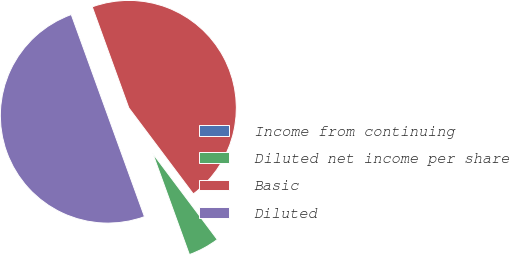<chart> <loc_0><loc_0><loc_500><loc_500><pie_chart><fcel>Income from continuing<fcel>Diluted net income per share<fcel>Basic<fcel>Diluted<nl><fcel>0.0%<fcel>4.71%<fcel>45.29%<fcel>50.0%<nl></chart> 